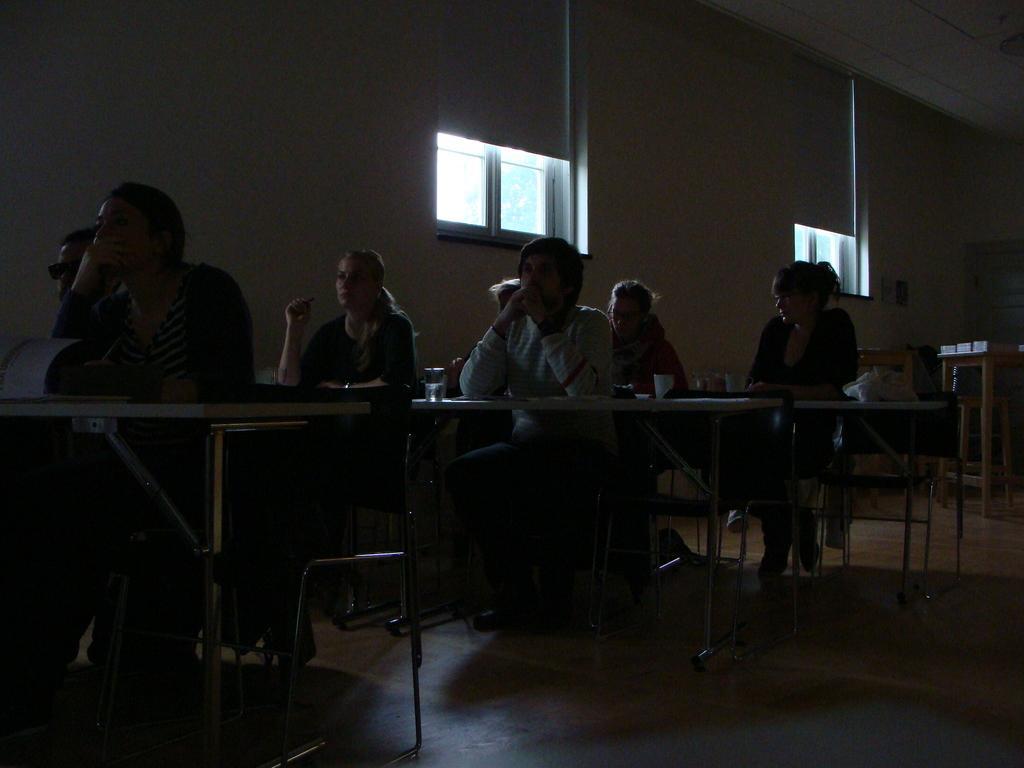Please provide a concise description of this image. The image is inside a room. There are tables and chairs. there are two windows. People are sitting on the chair in front of it there is table. On the table there is glass,paper. this is the floor. There are seven people in the image. 